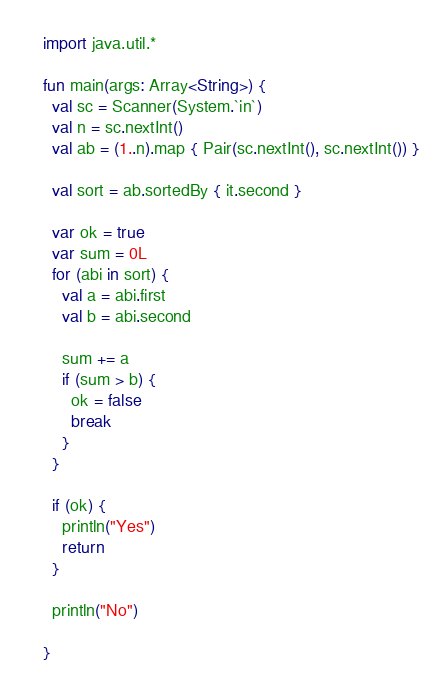Convert code to text. <code><loc_0><loc_0><loc_500><loc_500><_Kotlin_>import java.util.*

fun main(args: Array<String>) {
  val sc = Scanner(System.`in`)
  val n = sc.nextInt()
  val ab = (1..n).map { Pair(sc.nextInt(), sc.nextInt()) }

  val sort = ab.sortedBy { it.second }

  var ok = true
  var sum = 0L
  for (abi in sort) {
    val a = abi.first
    val b = abi.second

    sum += a
    if (sum > b) {
      ok = false
      break
    }
  }

  if (ok) {
    println("Yes")
    return
  }

  println("No")

}</code> 